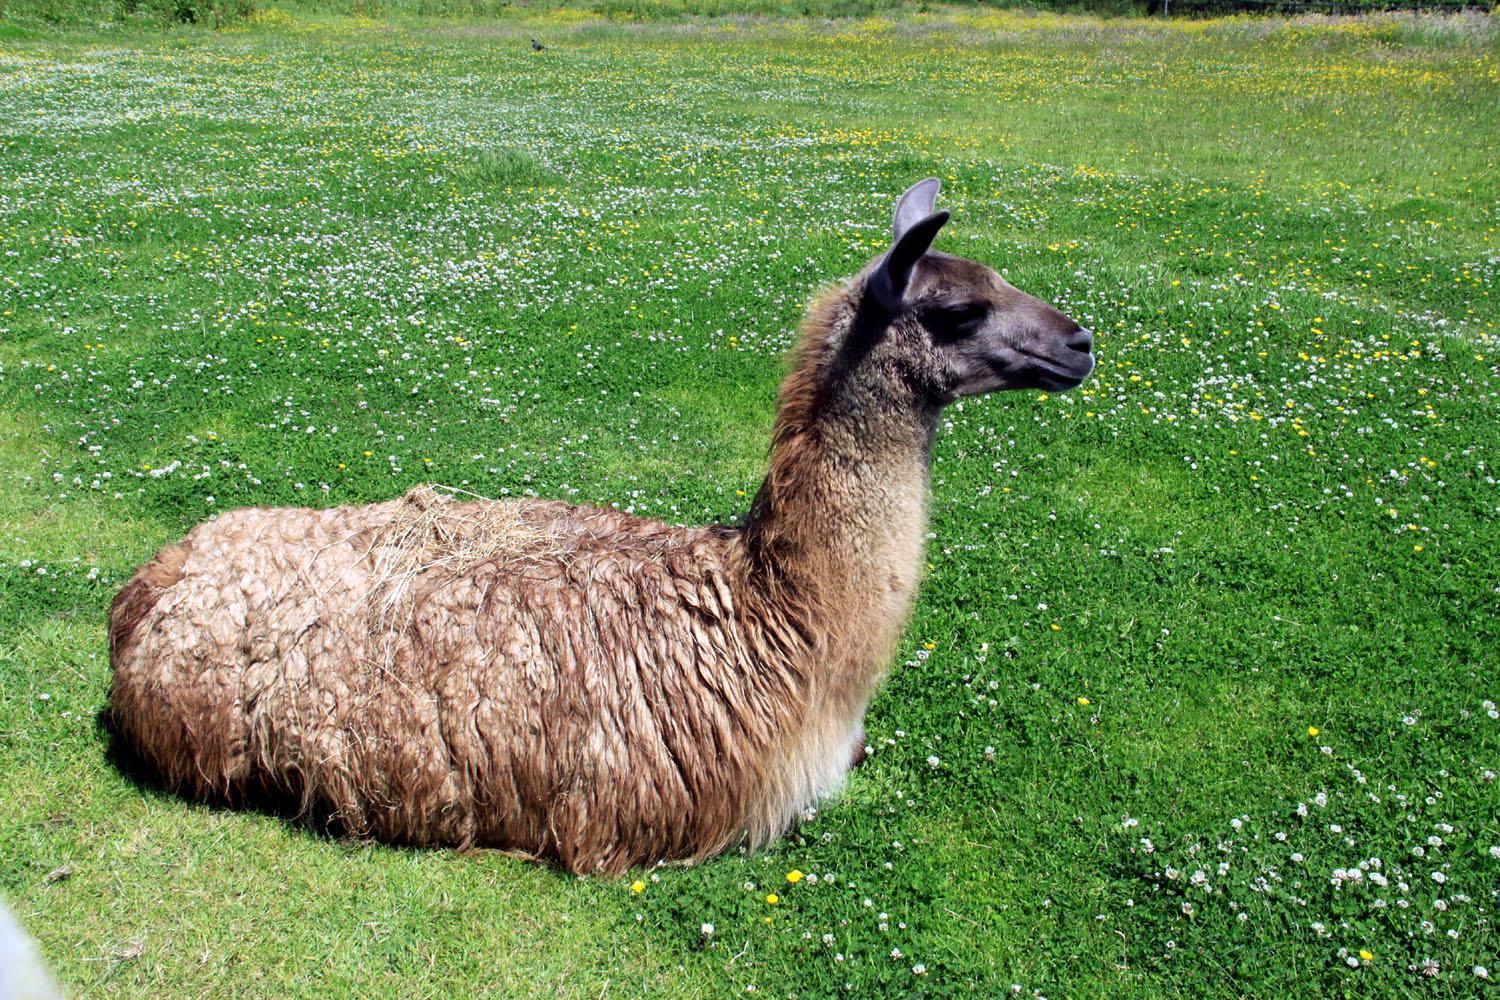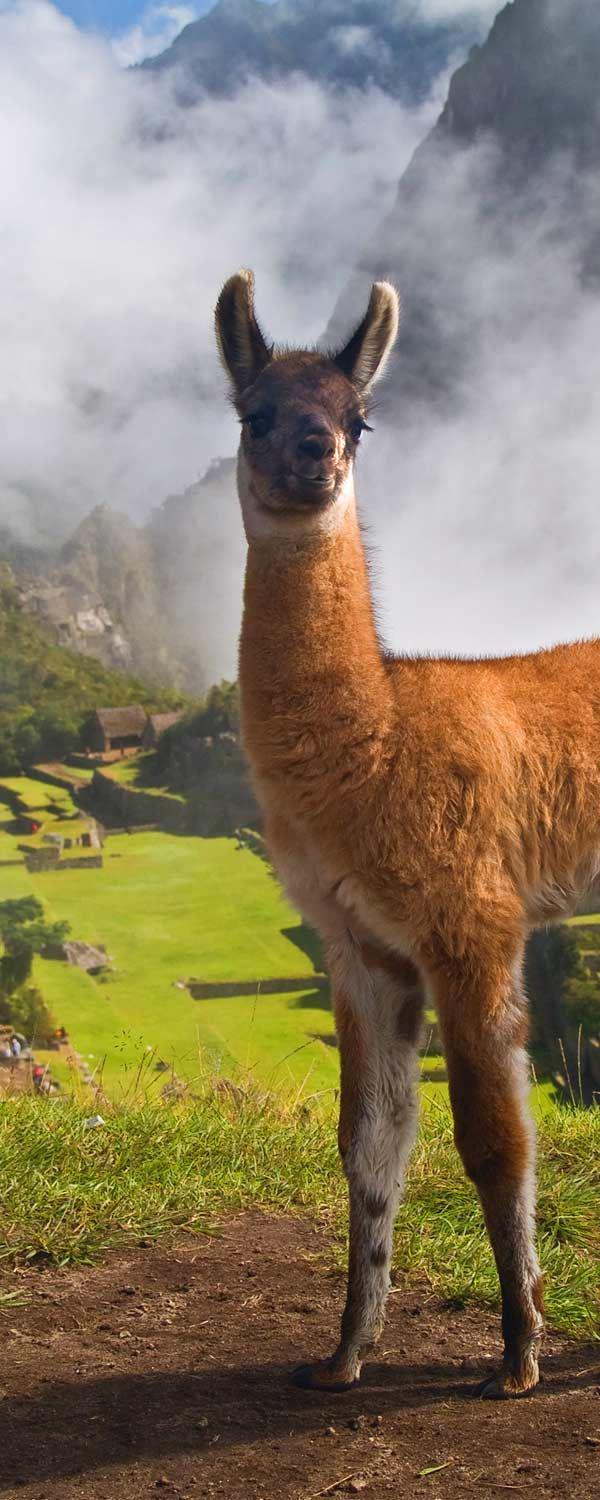The first image is the image on the left, the second image is the image on the right. Evaluate the accuracy of this statement regarding the images: "The llama in the foreground of the left image is standing with its body and head turned leftward, and the right image includes one young-looking llama with long legs who is standing in profile.". Is it true? Answer yes or no. No. The first image is the image on the left, the second image is the image on the right. Evaluate the accuracy of this statement regarding the images: "There are no more than two llamas.". Is it true? Answer yes or no. Yes. 